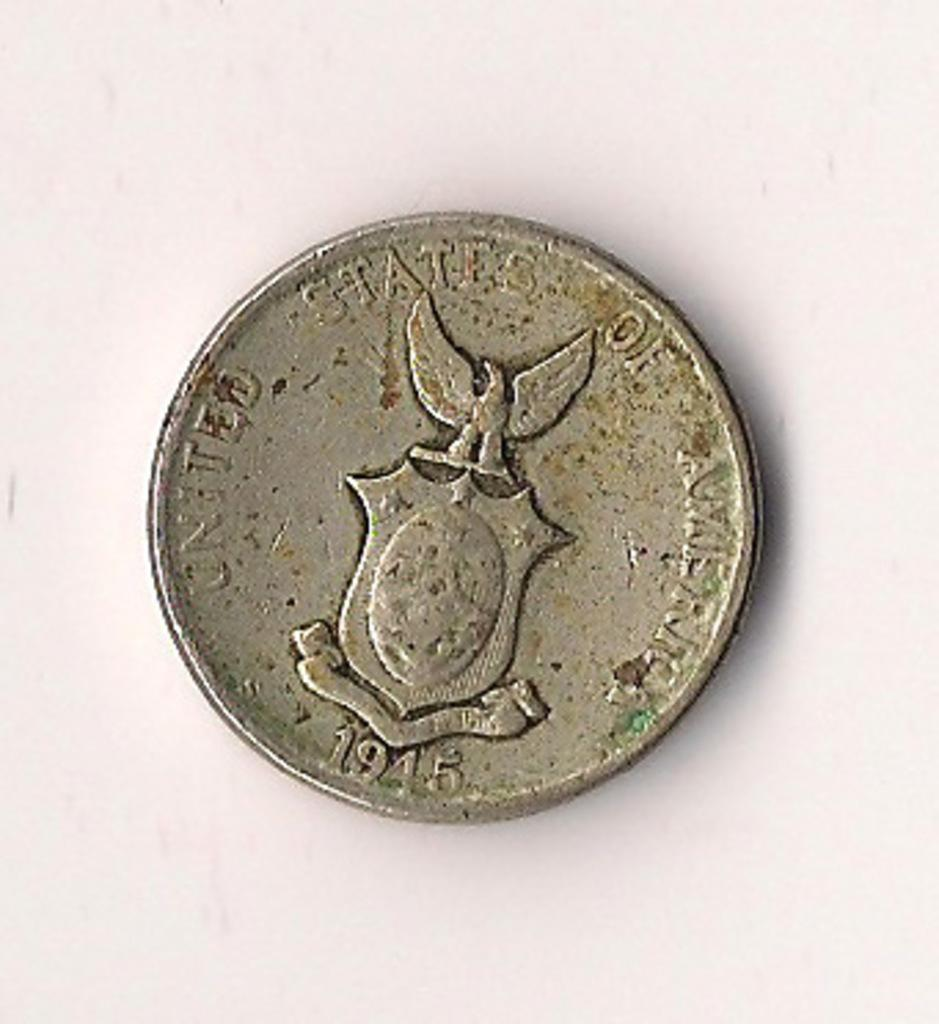<image>
Create a compact narrative representing the image presented. An old United States of America coin from 1945 